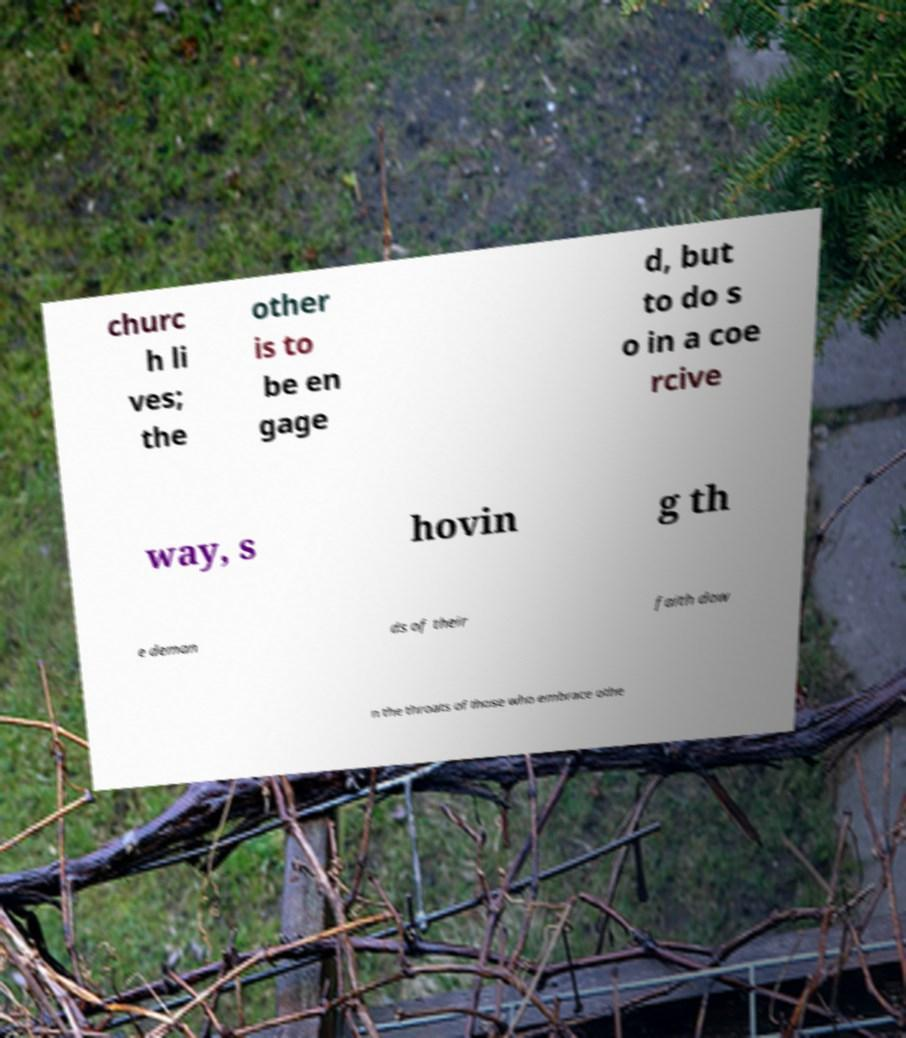Can you accurately transcribe the text from the provided image for me? churc h li ves; the other is to be en gage d, but to do s o in a coe rcive way, s hovin g th e deman ds of their faith dow n the throats of those who embrace othe 